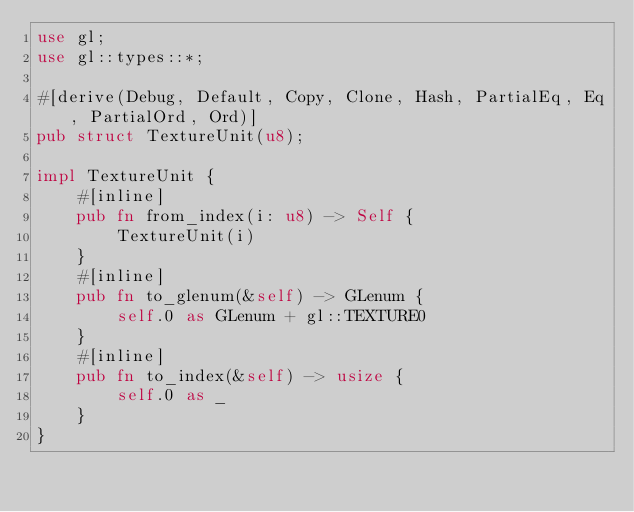Convert code to text. <code><loc_0><loc_0><loc_500><loc_500><_Rust_>use gl;
use gl::types::*;

#[derive(Debug, Default, Copy, Clone, Hash, PartialEq, Eq, PartialOrd, Ord)]
pub struct TextureUnit(u8);

impl TextureUnit {
    #[inline]
    pub fn from_index(i: u8) -> Self {
        TextureUnit(i)
    }
    #[inline]
    pub fn to_glenum(&self) -> GLenum {
        self.0 as GLenum + gl::TEXTURE0
    }
    #[inline]
    pub fn to_index(&self) -> usize {
        self.0 as _
    }
}


</code> 